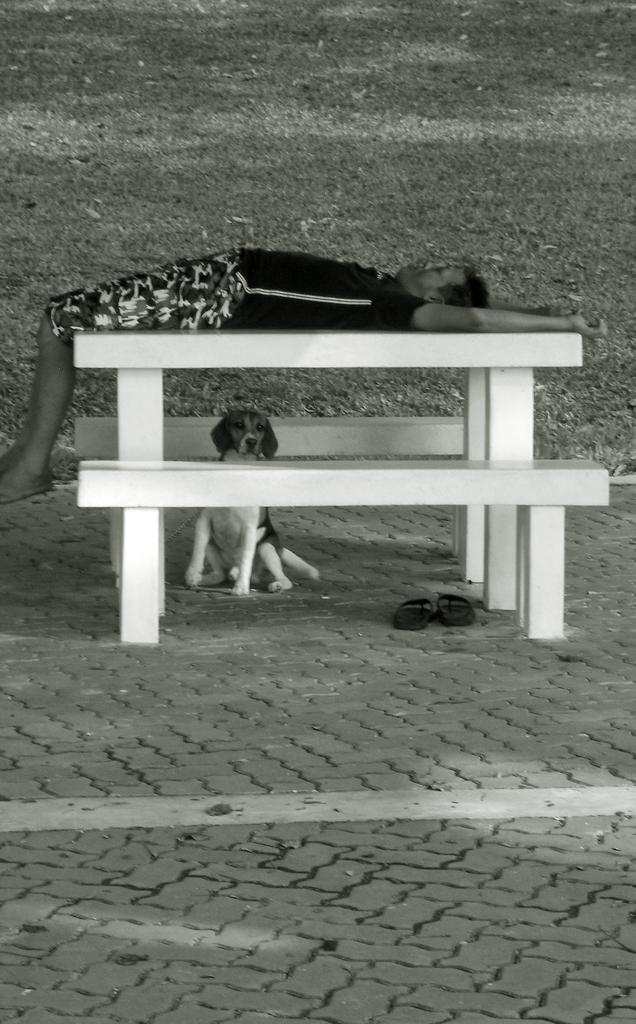What animal can be seen in the image? There is a dog in the image. Where is the dog located in relation to the table? The dog is sitting under the table. What is the man doing in the image? The man is lying on the table. What color scheme is used in the image? The image is in black and white color. How many icicles are hanging from the table in the image? There are no icicles present in the image. What process is being carried out in the room depicted in the image? The image does not show a room, and no specific process is being carried out. 